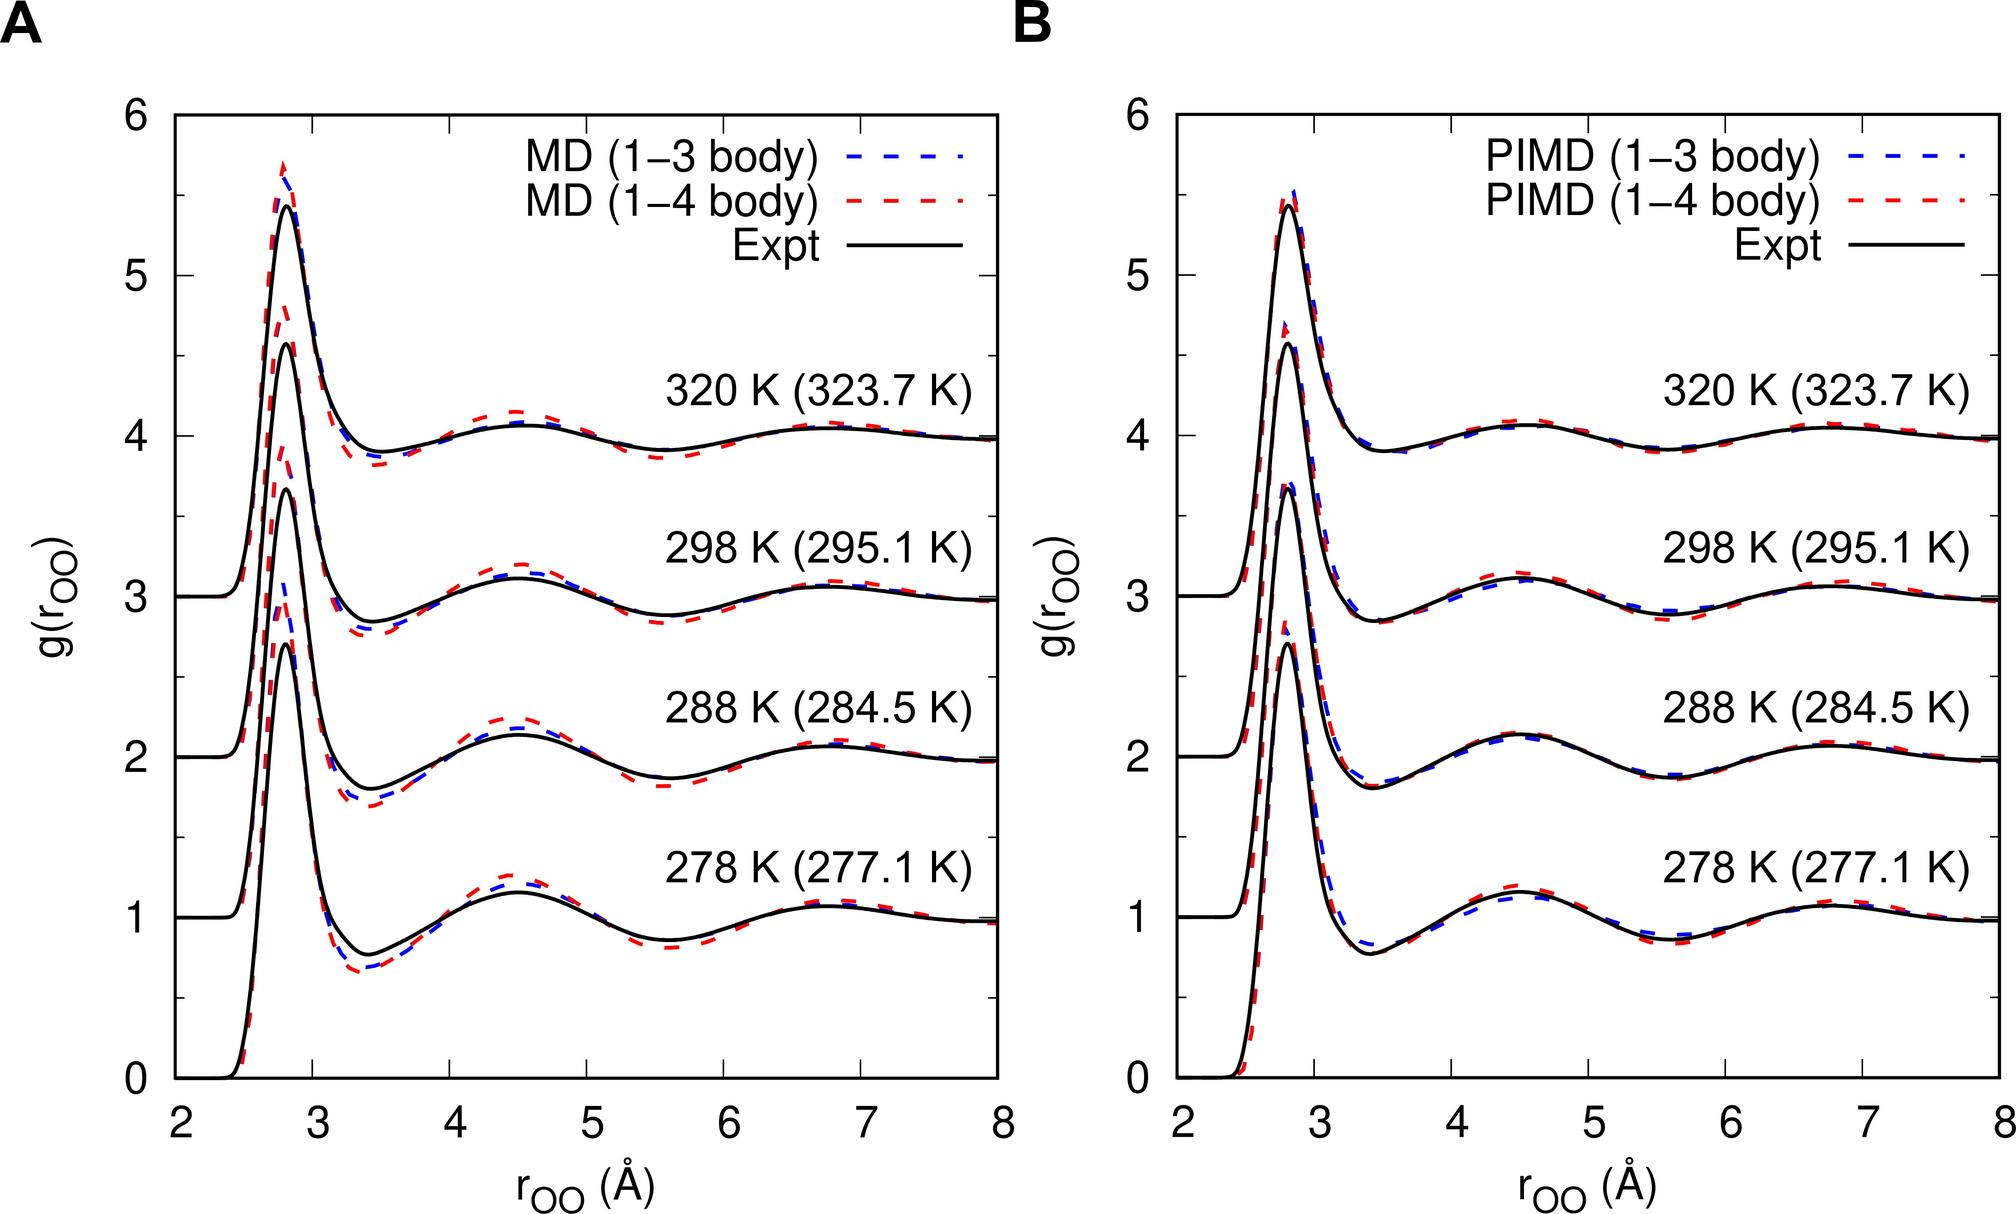Based on Figure B, which method shows a closer agreement with the experimental data for the first peak of g(r) at 298 K? MD (1-3 body) MD (1-4 body) PIMD (1-3 body) PIMD (1-4 body) When analyzing the graph in Figure B, the experimental data at the 298 K temperature level closely aligns with the curve of the PIMD (1-4 body) method. This indicates that this simulation technique most accurately reflects the real-world measurements among the other methods tested for the first peak of the radial distribution function, g(r). Moreover, this superior agreement suggests that incorporating both 1-4 body interactions in PIMD might capture essential molecular interactions, making it particularly adept at modeling systems at this temperature. 